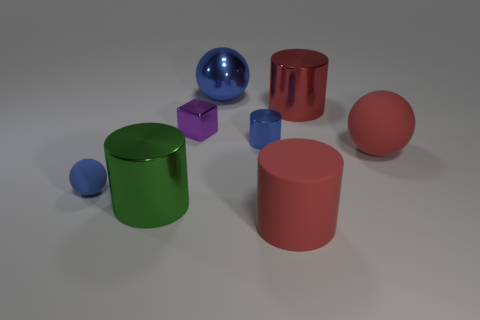Subtract 1 cylinders. How many cylinders are left? 3 Subtract all green spheres. Subtract all red blocks. How many spheres are left? 3 Add 1 tiny rubber balls. How many objects exist? 9 Subtract all balls. How many objects are left? 5 Add 5 large blue balls. How many large blue balls exist? 6 Subtract 0 blue cubes. How many objects are left? 8 Subtract all small gray cylinders. Subtract all purple metallic blocks. How many objects are left? 7 Add 1 big red metal cylinders. How many big red metal cylinders are left? 2 